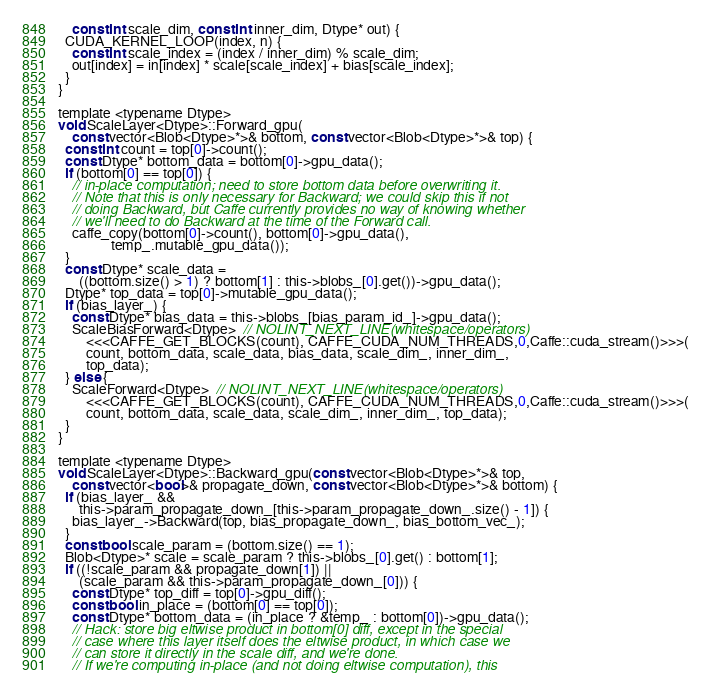Convert code to text. <code><loc_0><loc_0><loc_500><loc_500><_Cuda_>    const int scale_dim, const int inner_dim, Dtype* out) {
  CUDA_KERNEL_LOOP(index, n) {
    const int scale_index = (index / inner_dim) % scale_dim;
    out[index] = in[index] * scale[scale_index] + bias[scale_index];
  }
}

template <typename Dtype>
void ScaleLayer<Dtype>::Forward_gpu(
    const vector<Blob<Dtype>*>& bottom, const vector<Blob<Dtype>*>& top) {
  const int count = top[0]->count();
  const Dtype* bottom_data = bottom[0]->gpu_data();
  if (bottom[0] == top[0]) {
    // in-place computation; need to store bottom data before overwriting it.
    // Note that this is only necessary for Backward; we could skip this if not
    // doing Backward, but Caffe currently provides no way of knowing whether
    // we'll need to do Backward at the time of the Forward call.
    caffe_copy(bottom[0]->count(), bottom[0]->gpu_data(),
               temp_.mutable_gpu_data());
  }
  const Dtype* scale_data =
      ((bottom.size() > 1) ? bottom[1] : this->blobs_[0].get())->gpu_data();
  Dtype* top_data = top[0]->mutable_gpu_data();
  if (bias_layer_) {
    const Dtype* bias_data = this->blobs_[bias_param_id_]->gpu_data();
    ScaleBiasForward<Dtype>  // NOLINT_NEXT_LINE(whitespace/operators)
        <<<CAFFE_GET_BLOCKS(count), CAFFE_CUDA_NUM_THREADS,0,Caffe::cuda_stream()>>>(
        count, bottom_data, scale_data, bias_data, scale_dim_, inner_dim_,
        top_data);
  } else {
    ScaleForward<Dtype>  // NOLINT_NEXT_LINE(whitespace/operators)
        <<<CAFFE_GET_BLOCKS(count), CAFFE_CUDA_NUM_THREADS,0,Caffe::cuda_stream()>>>(
        count, bottom_data, scale_data, scale_dim_, inner_dim_, top_data);
  }
}

template <typename Dtype>
void ScaleLayer<Dtype>::Backward_gpu(const vector<Blob<Dtype>*>& top,
    const vector<bool>& propagate_down, const vector<Blob<Dtype>*>& bottom) {
  if (bias_layer_ &&
      this->param_propagate_down_[this->param_propagate_down_.size() - 1]) {
    bias_layer_->Backward(top, bias_propagate_down_, bias_bottom_vec_);
  }
  const bool scale_param = (bottom.size() == 1);
  Blob<Dtype>* scale = scale_param ? this->blobs_[0].get() : bottom[1];
  if ((!scale_param && propagate_down[1]) ||
      (scale_param && this->param_propagate_down_[0])) {
    const Dtype* top_diff = top[0]->gpu_diff();
    const bool in_place = (bottom[0] == top[0]);
    const Dtype* bottom_data = (in_place ? &temp_ : bottom[0])->gpu_data();
    // Hack: store big eltwise product in bottom[0] diff, except in the special
    // case where this layer itself does the eltwise product, in which case we
    // can store it directly in the scale diff, and we're done.
    // If we're computing in-place (and not doing eltwise computation), this</code> 